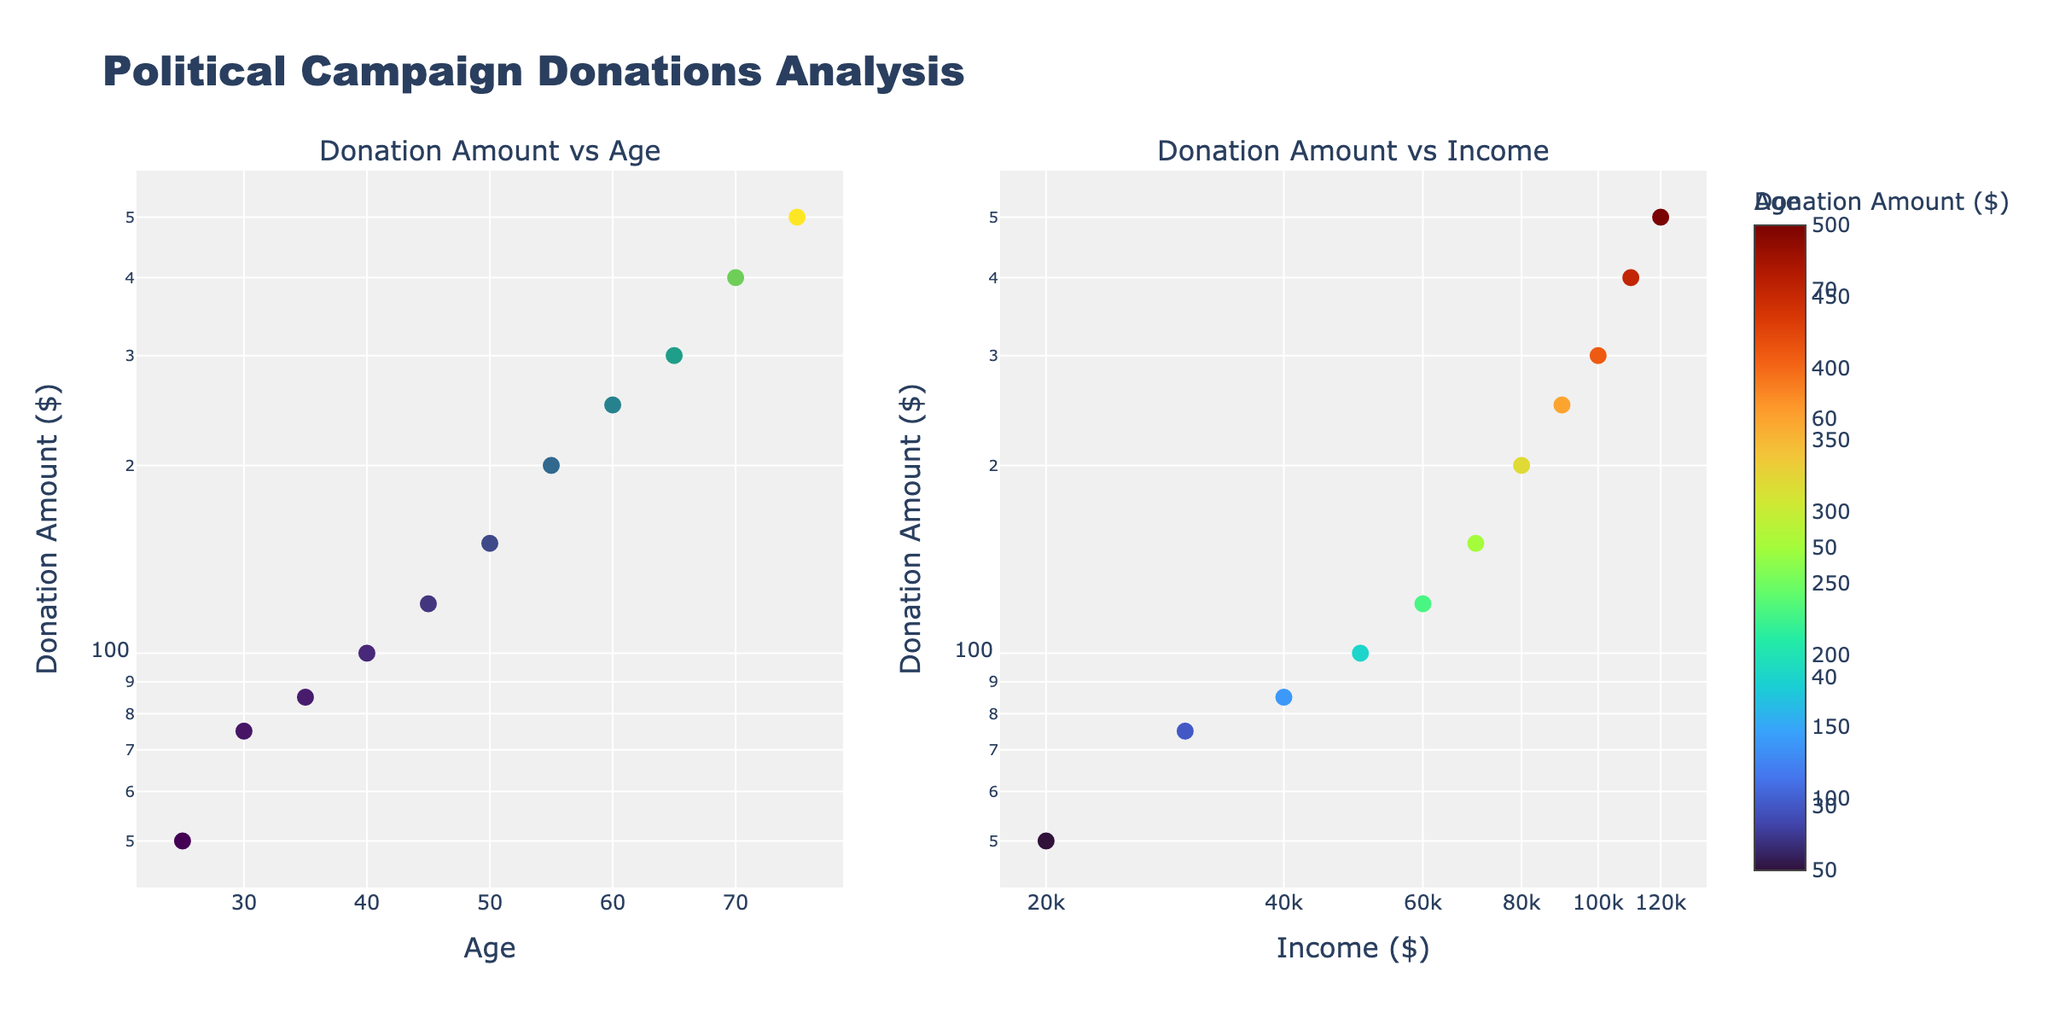What is the title of the subplots? The title is displayed at the top center of the figure above the subplots. It reads "Political Campaign Donations Analysis".
Answer: Political Campaign Donations Analysis How many data points are represented in each subplot? Each subplot has markers representing data points. By counting the markers, we see that there are 11 data points on each subplot.
Answer: 11 Which subplot shows Donation Amount versus Age? The first subplot on the left shows Donation Amount versus Age. This is indicated by the x-axis labeled "Age" and the y-axis labeled "Donation Amount ($)".
Answer: The one on the left What color scale is used for the markers in the first subplot? The first subplot uses a color scale for the markers that ranges from a darker color to a lighter one. This scale is labeled "Donation Amount ($)" in the adjacent color bar.
Answer: Viridis What is the donation amount for the data point at age 60? Identify the data point where the x-value (Age) is 60 in the left subplot. The y-value representing Donation Amount is 250.
Answer: 250 Which political interest corresponds to the highest donation amount on the income subplot? Find the highest y-value (Donation Amount) in the right subplot. The tooltip or legend shows that the highest donation amount of 500 corresponds to "Democracy".
Answer: Democracy Which age group shows the highest donation amount? Look at the left subplot and observe which age-related data point has the highest y-value. The data point for age 75 shows the highest donation amount of 500.
Answer: Age 75 At what income level does the donation amount reach 150? On the right subplot, find the data point where the y-value (Donation Amount) is 150. The x-value representing Income at this point is 70,000.
Answer: 70,000 Are the donation amounts more correlated with age or income? Looking at both subplots, the relationship between Donation Amount and Age seems more spread out and less steep than Donation Amount versus Income, indicating a stronger visual correlation with Income.
Answer: More correlated with Income Explain the trend in donation amounts as age increases? In the left subplot, the donation amounts generally increase as the age increases. This can be seen clearly on a log scale, where the higher age groups (60, 65, 70, 75) have higher donation amounts compared to the younger groups.
Answer: Increase 